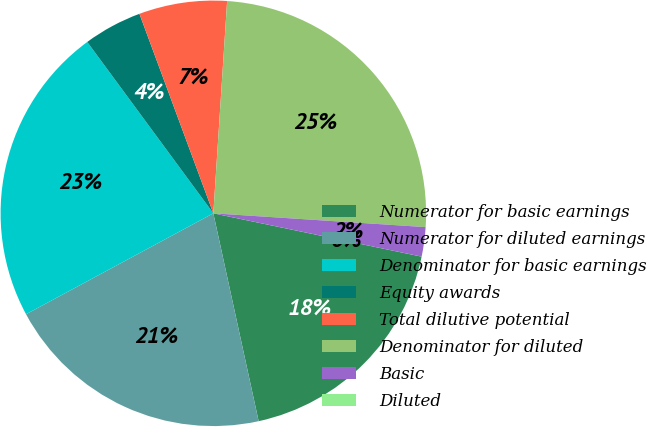Convert chart. <chart><loc_0><loc_0><loc_500><loc_500><pie_chart><fcel>Numerator for basic earnings<fcel>Numerator for diluted earnings<fcel>Denominator for basic earnings<fcel>Equity awards<fcel>Total dilutive potential<fcel>Denominator for diluted<fcel>Basic<fcel>Diluted<nl><fcel>18.32%<fcel>20.55%<fcel>22.77%<fcel>4.45%<fcel>6.68%<fcel>25.0%<fcel>2.23%<fcel>0.0%<nl></chart> 